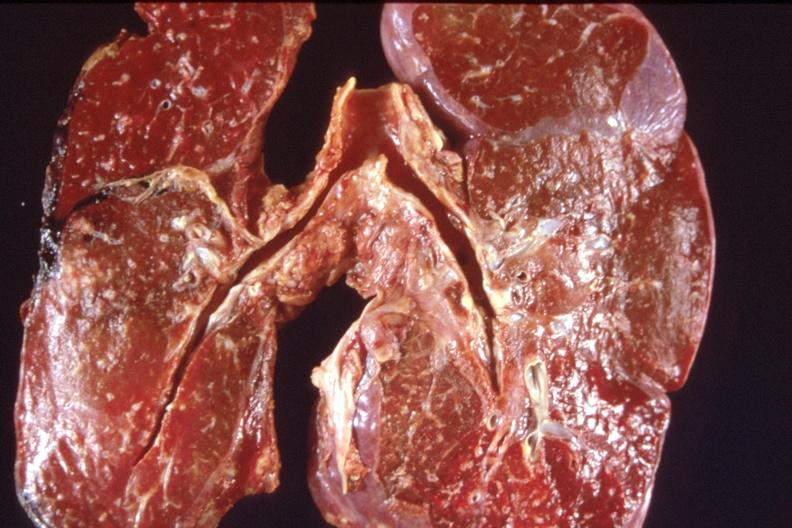what is present?
Answer the question using a single word or phrase. Respiratory 